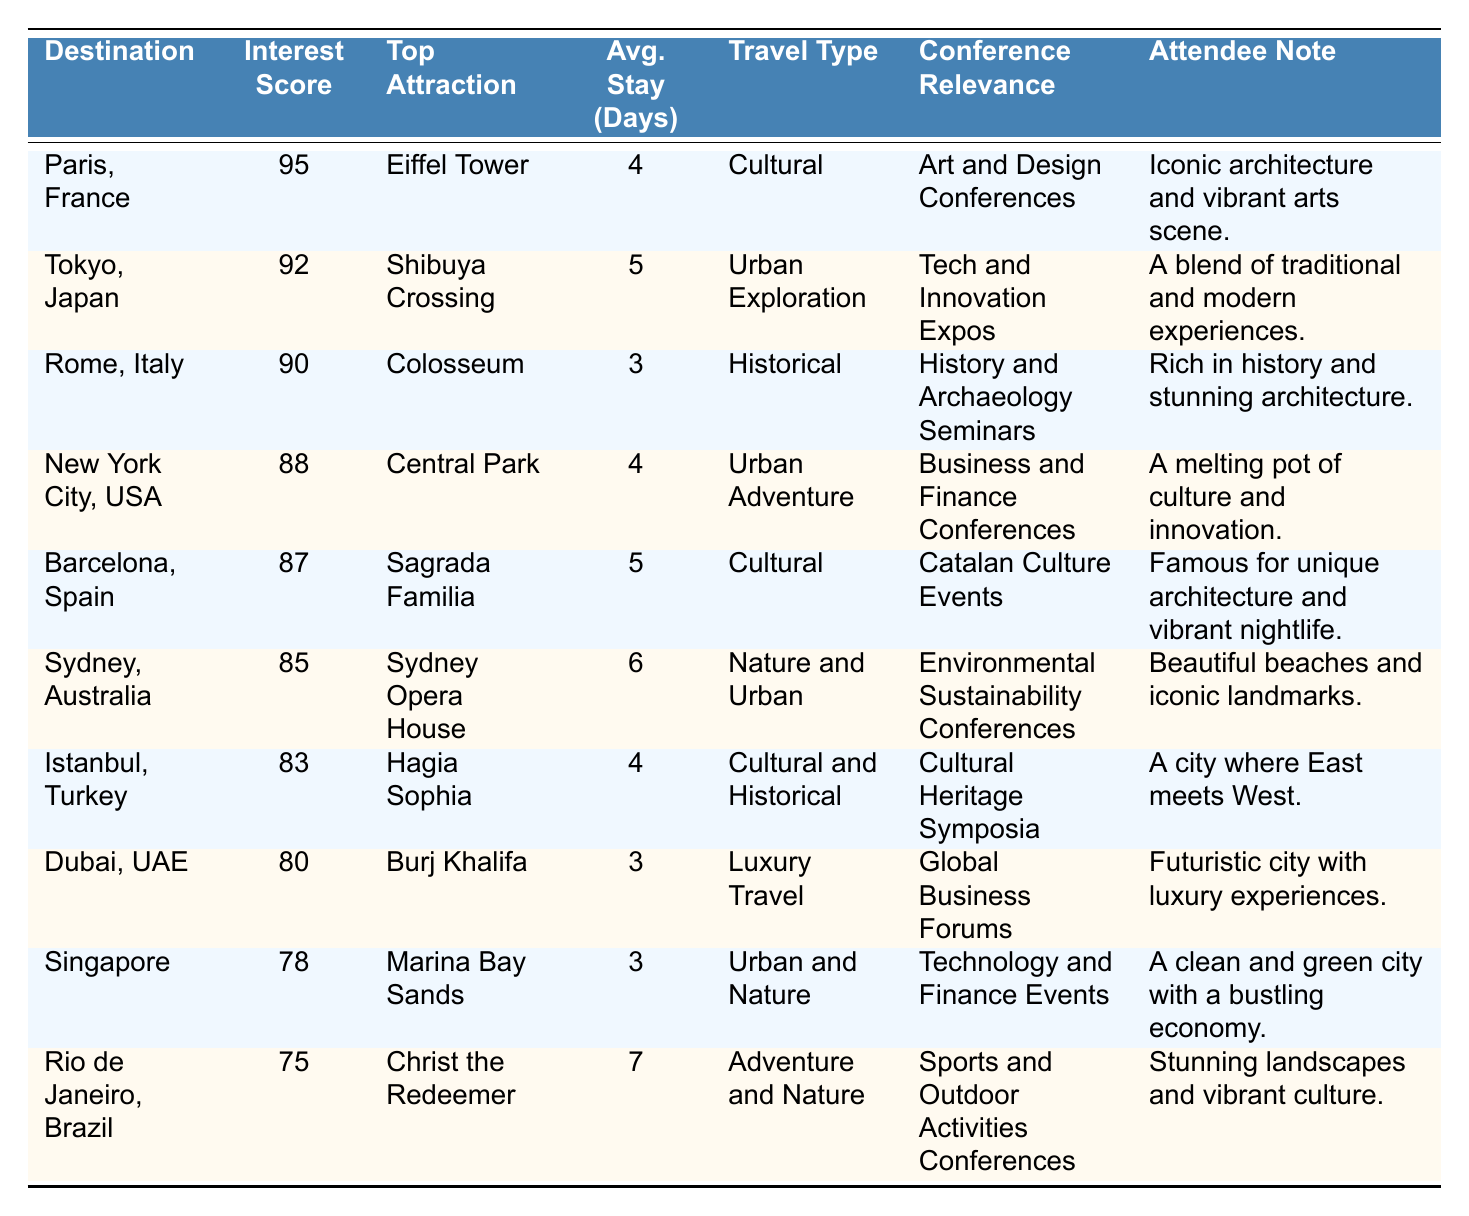What is the top attraction in Paris, France? According to the table, the top attraction listed for Paris, France, is the Eiffel Tower.
Answer: Eiffel Tower Which destination has the highest interest score? The table shows that Paris, France, has the highest interest score of 95.
Answer: Paris, France What is the average stay duration in days for travelers to Sydney, Australia? The table specifies that the average stay duration in days for Sydney, Australia, is 6 days.
Answer: 6 days Is the average stay in Singapore longer than that in Dubai? The table indicates Singapore has an average stay of 3 days while Dubai also has an average stay of 3 days, meaning they are equal.
Answer: No Which destination's top attraction is the Christ the Redeemer? The table reveals that the top attraction for Rio de Janeiro, Brazil, is the Christ the Redeemer.
Answer: Rio de Janeiro, Brazil What is the difference in interest scores between Tokyo, Japan, and Barcelona, Spain? The interest score for Tokyo is 92, and for Barcelona, it is 87. The difference is 92 - 87 = 5.
Answer: 5 Which destinations have a travel type categorized as "Cultural"? The table lists Paris, France; Barcelona, Spain; and Istanbul, Turkey as destinations with a "Cultural" travel type.
Answer: Paris, France; Barcelona, Spain; Istanbul, Turkey What is the average stay duration for the top three ranked destinations? The average stay for the top three destinations (Paris, Rome, Tokyo) is (4 + 3 + 5)/3 = 4 days.
Answer: 4 days Are there more culturally focused conferences in the list than luxury travel ones? The table indicates there are four entries related to cultural conferences (Paris, Barcelona, Istanbul, and Rome) and one entry for luxury travel (Dubai), so yes, there are more cultural entries.
Answer: Yes What is the total interest score of all destinations listed? The total interest score can be calculated by adding all the interest scores: 95 + 92 + 90 + 88 + 87 + 85 + 83 + 80 + 78 + 75 = 918.
Answer: 918 